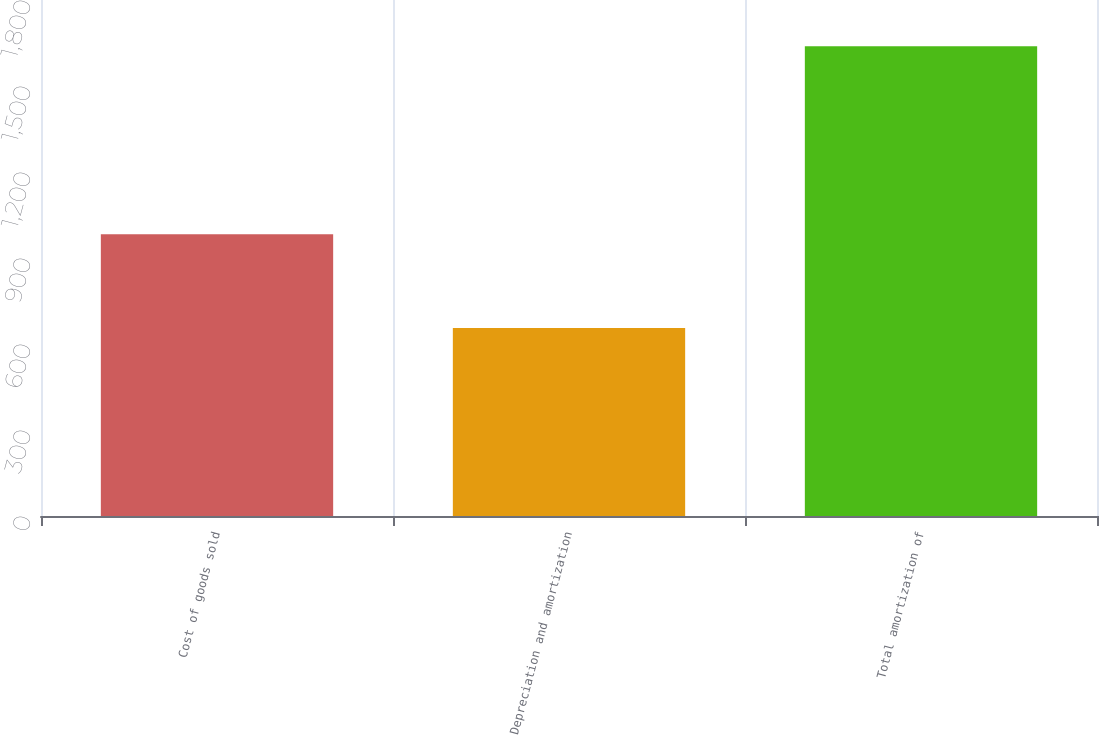Convert chart to OTSL. <chart><loc_0><loc_0><loc_500><loc_500><bar_chart><fcel>Cost of goods sold<fcel>Depreciation and amortization<fcel>Total amortization of<nl><fcel>983<fcel>656<fcel>1639<nl></chart> 